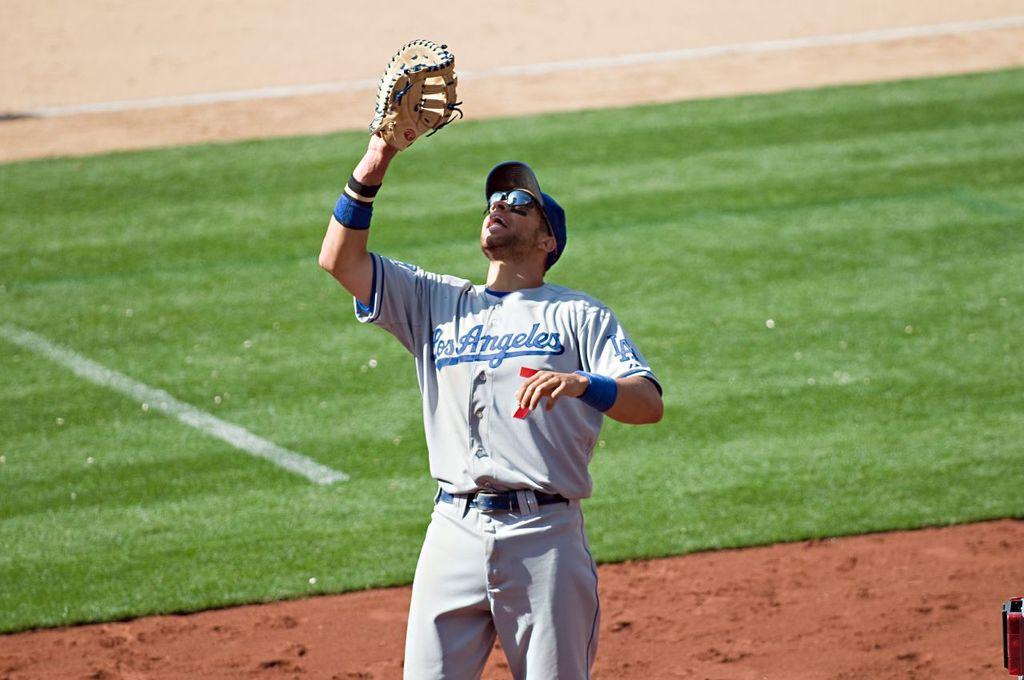What city is written on the player's jersey?
Ensure brevity in your answer.  Los angeles. What number does the player have?
Make the answer very short. 7. 